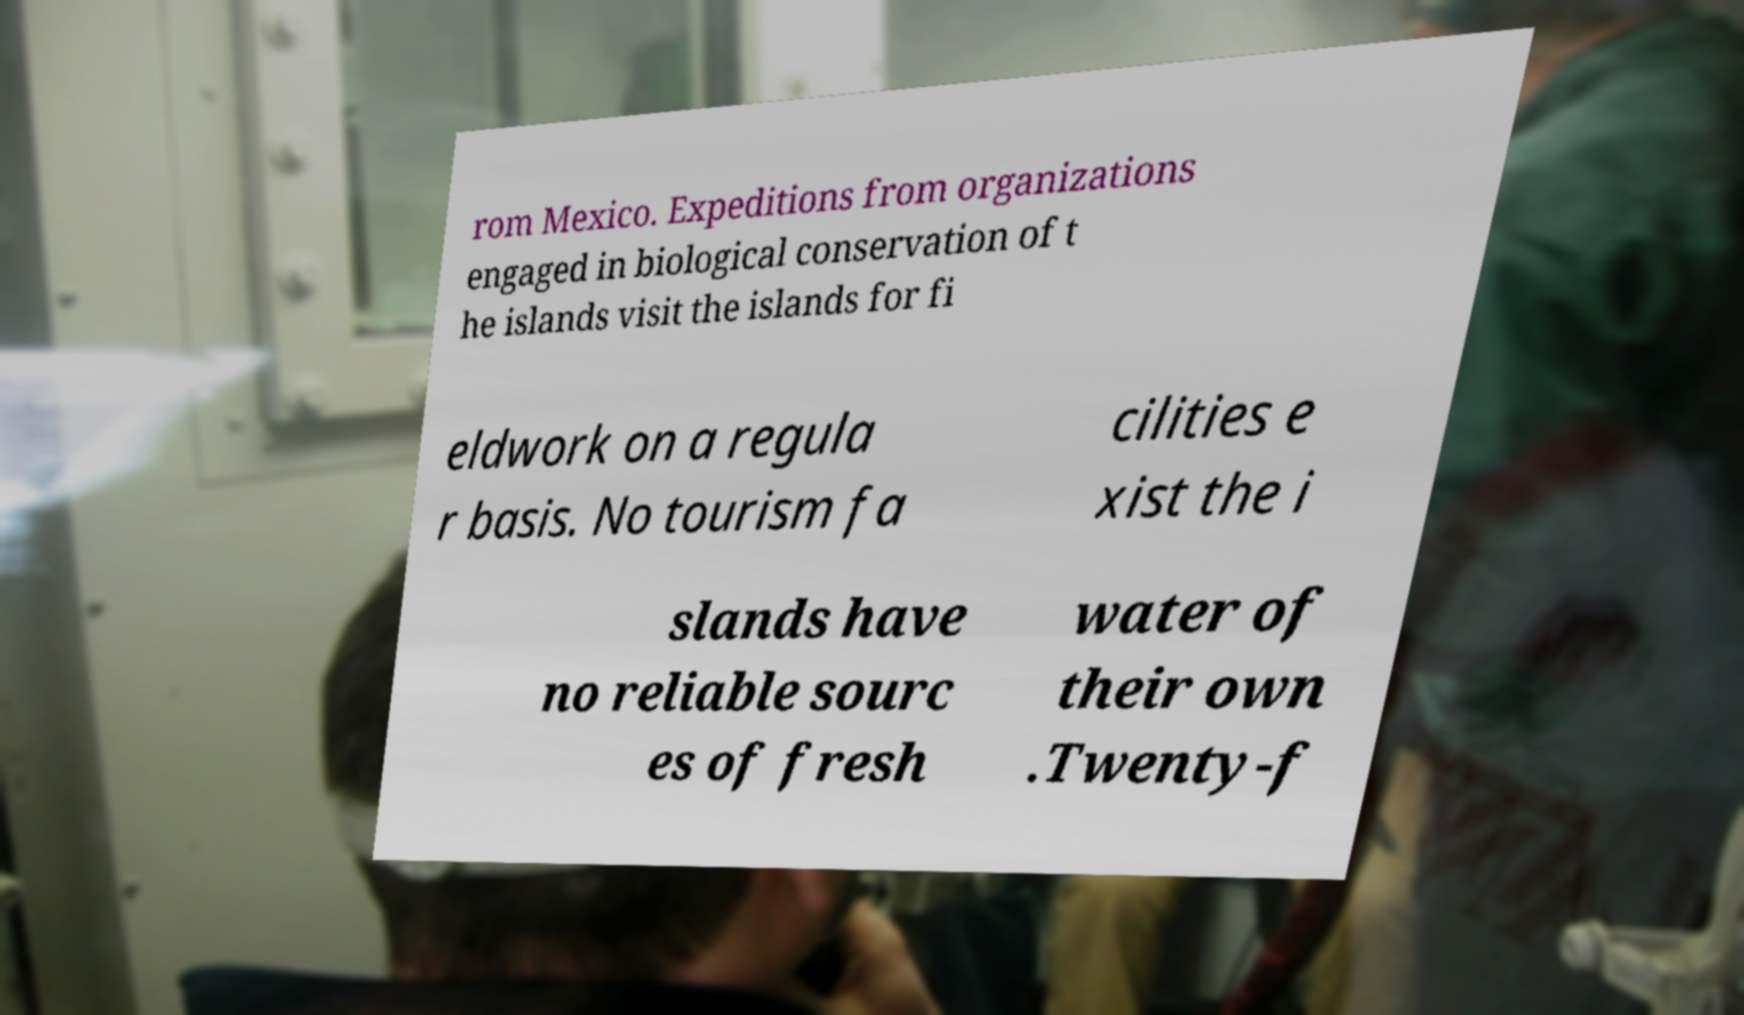For documentation purposes, I need the text within this image transcribed. Could you provide that? rom Mexico. Expeditions from organizations engaged in biological conservation of t he islands visit the islands for fi eldwork on a regula r basis. No tourism fa cilities e xist the i slands have no reliable sourc es of fresh water of their own .Twenty-f 